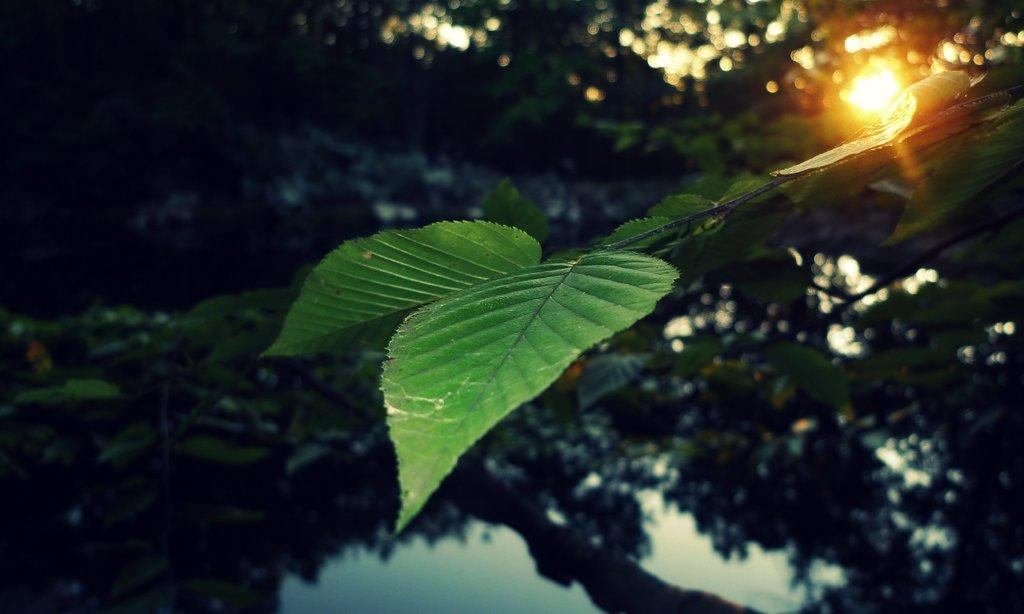What type of vegetation can be seen in the image? There are trees in the image. What part of the trees can be seen in the image? Leaves are visible in the image. What is located at the bottom of the image? There is water at the bottom of the image. What celestial body can be seen in the background of the image? The sun is visible in the background of the image. How many oranges are hanging from the trees in the image? There are no oranges present in the image; it features trees with leaves. Can you see a boot in the image? There is no boot present in the image. 